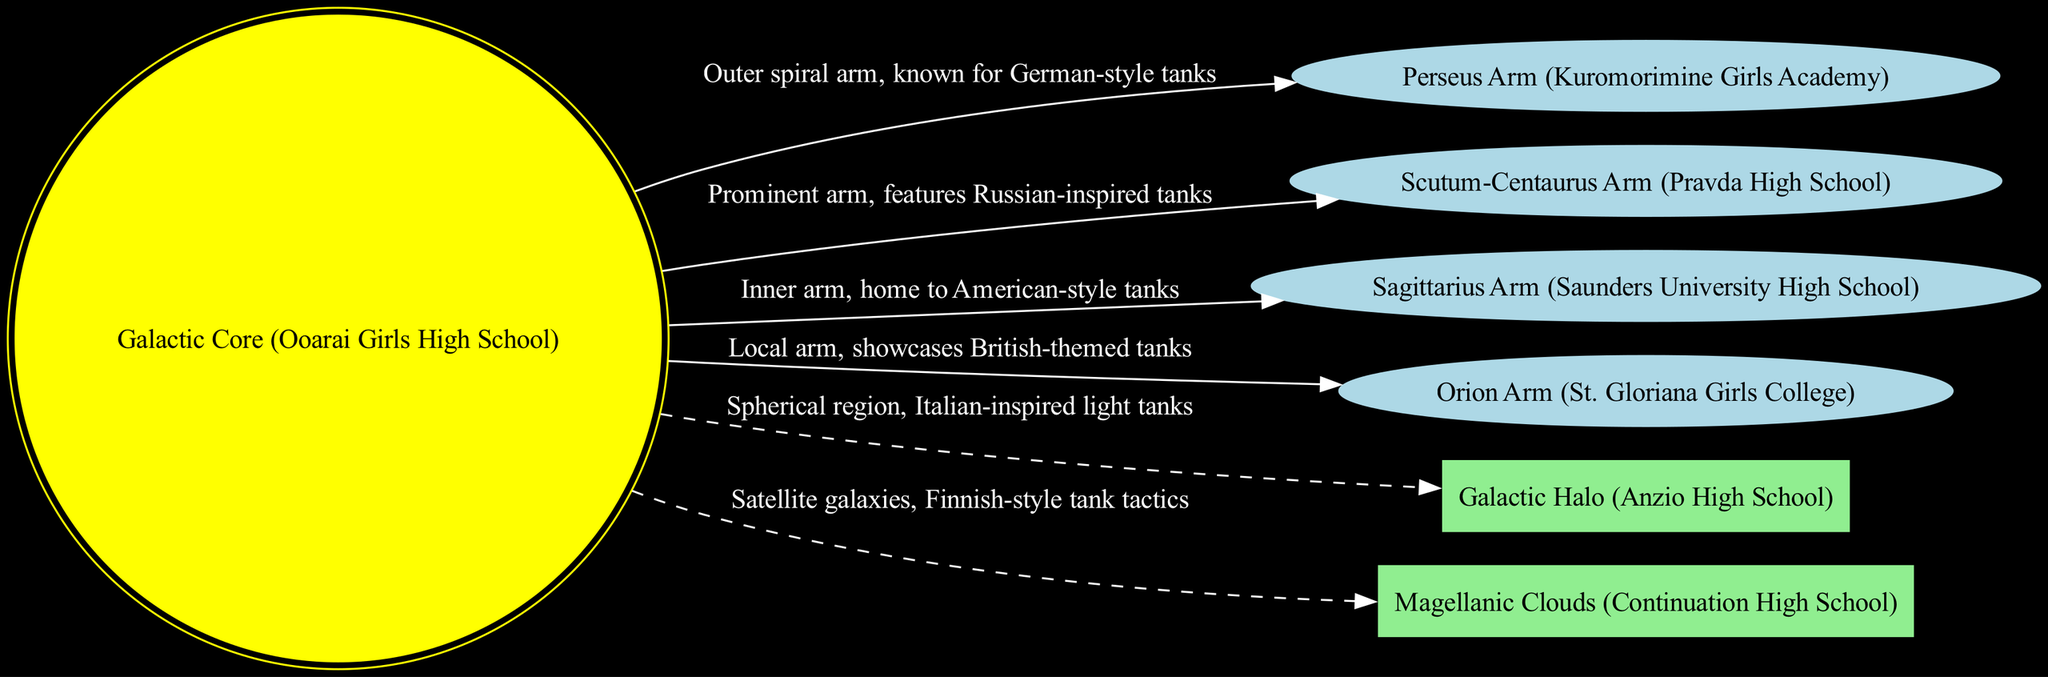What is the name of the galactic core? The diagram displays the galactic core labeled as "Galactic Core (Ooarai Girls High School)", which is indicated at the center of the diagram.
Answer: Galactic Core (Ooarai Girls High School) How many arms are in the diagram? The diagram lists four arms: Perseus Arm, Scutum-Centaurus Arm, Sagittarius Arm, and Orion Arm. Counting these arms gives a total of four.
Answer: 4 Which arm is associated with Russian-inspired tanks? The arm labeled as "Scutum-Centaurus Arm (Pravda High School)" describes its association with Russian-inspired tanks, making it the correct answer.
Answer: Scutum-Centaurus Arm (Pravda High School) What color is used for the nodes representing the galactic core? The galactic core node is represented in yellow as indicated by the attributes of the node in the diagram code.
Answer: Yellow List one feature described as having Italian-inspired light tanks. The feature named "Galactic Halo (Anzio High School)" is specified as having Italian-inspired light tanks in the diagram.
Answer: Galactic Halo (Anzio High School) Which arm represents German-style tanks? The "Perseus Arm (Kuromorimine Girls Academy)" is the arm that is described as featuring German-style tanks, according to the labels in the diagram.
Answer: Perseus Arm (Kuromorimine Girls Academy) Identify the feature that consists of satellite galaxies. The diagram mentions "Magellanic Clouds (Continuation High School)" as a feature, which is specifically noted to consist of satellite galaxies.
Answer: Magellanic Clouds (Continuation High School) What visual style distinguishes the edges connecting features to the core? The edges connecting the features to the core are shown as dashed lines, which is specified in the attributes of the diagram's edges.
Answer: Dashed lines Which arm is identified as the local arm? The "Orion Arm (St. Gloriana Girls College)" is described as the local arm in the diagram, making it the answer to this question.
Answer: Orion Arm (St. Gloriana Girls College) 